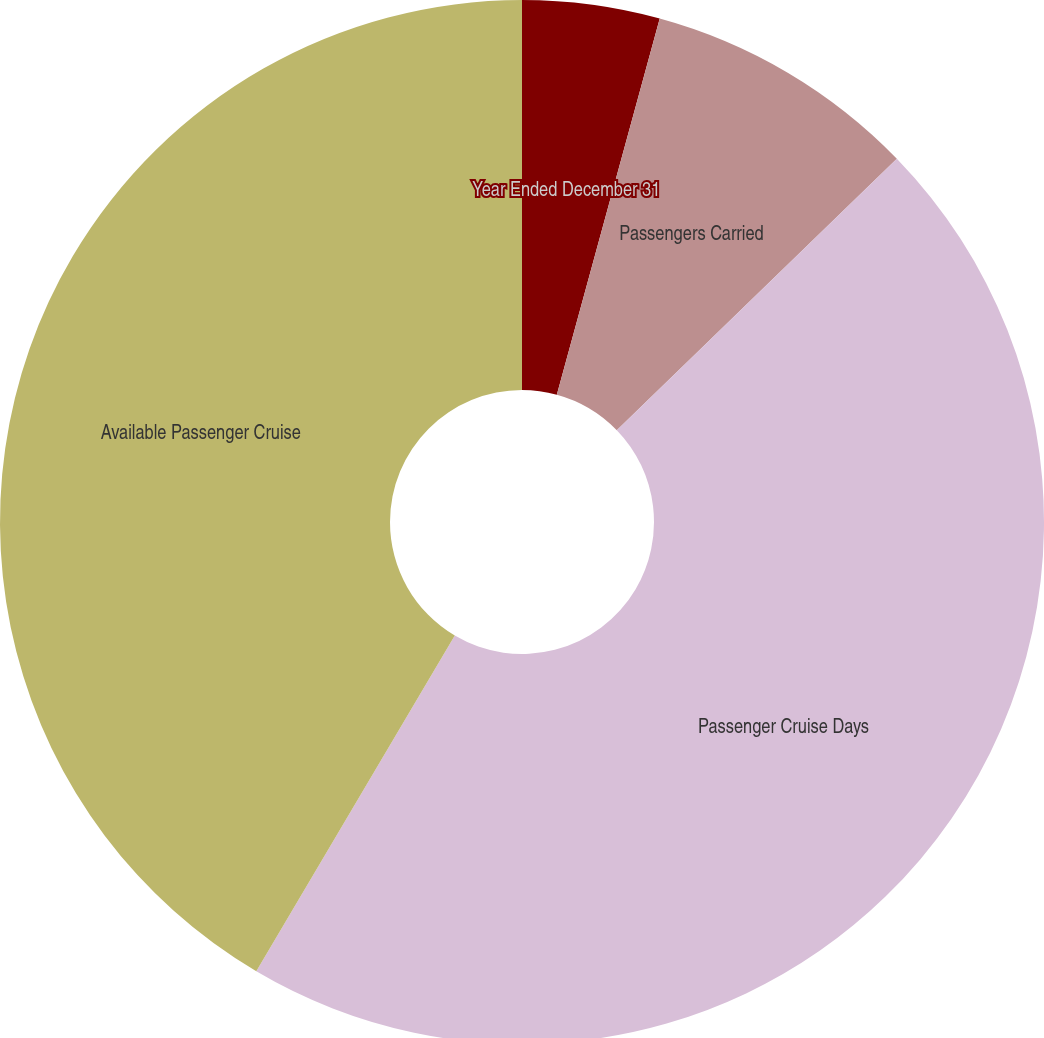<chart> <loc_0><loc_0><loc_500><loc_500><pie_chart><fcel>Year Ended December 31<fcel>Passengers Carried<fcel>Passenger Cruise Days<fcel>Available Passenger Cruise<fcel>Occupancy<nl><fcel>4.25%<fcel>8.5%<fcel>45.75%<fcel>41.5%<fcel>0.0%<nl></chart> 